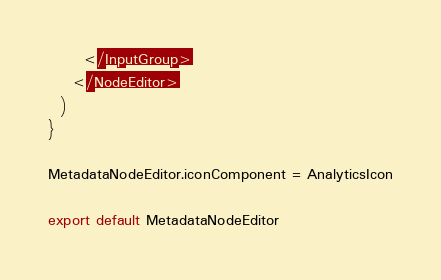<code> <loc_0><loc_0><loc_500><loc_500><_TypeScript_>      </InputGroup>
    </NodeEditor>
  )
}

MetadataNodeEditor.iconComponent = AnalyticsIcon

export default MetadataNodeEditor
</code> 